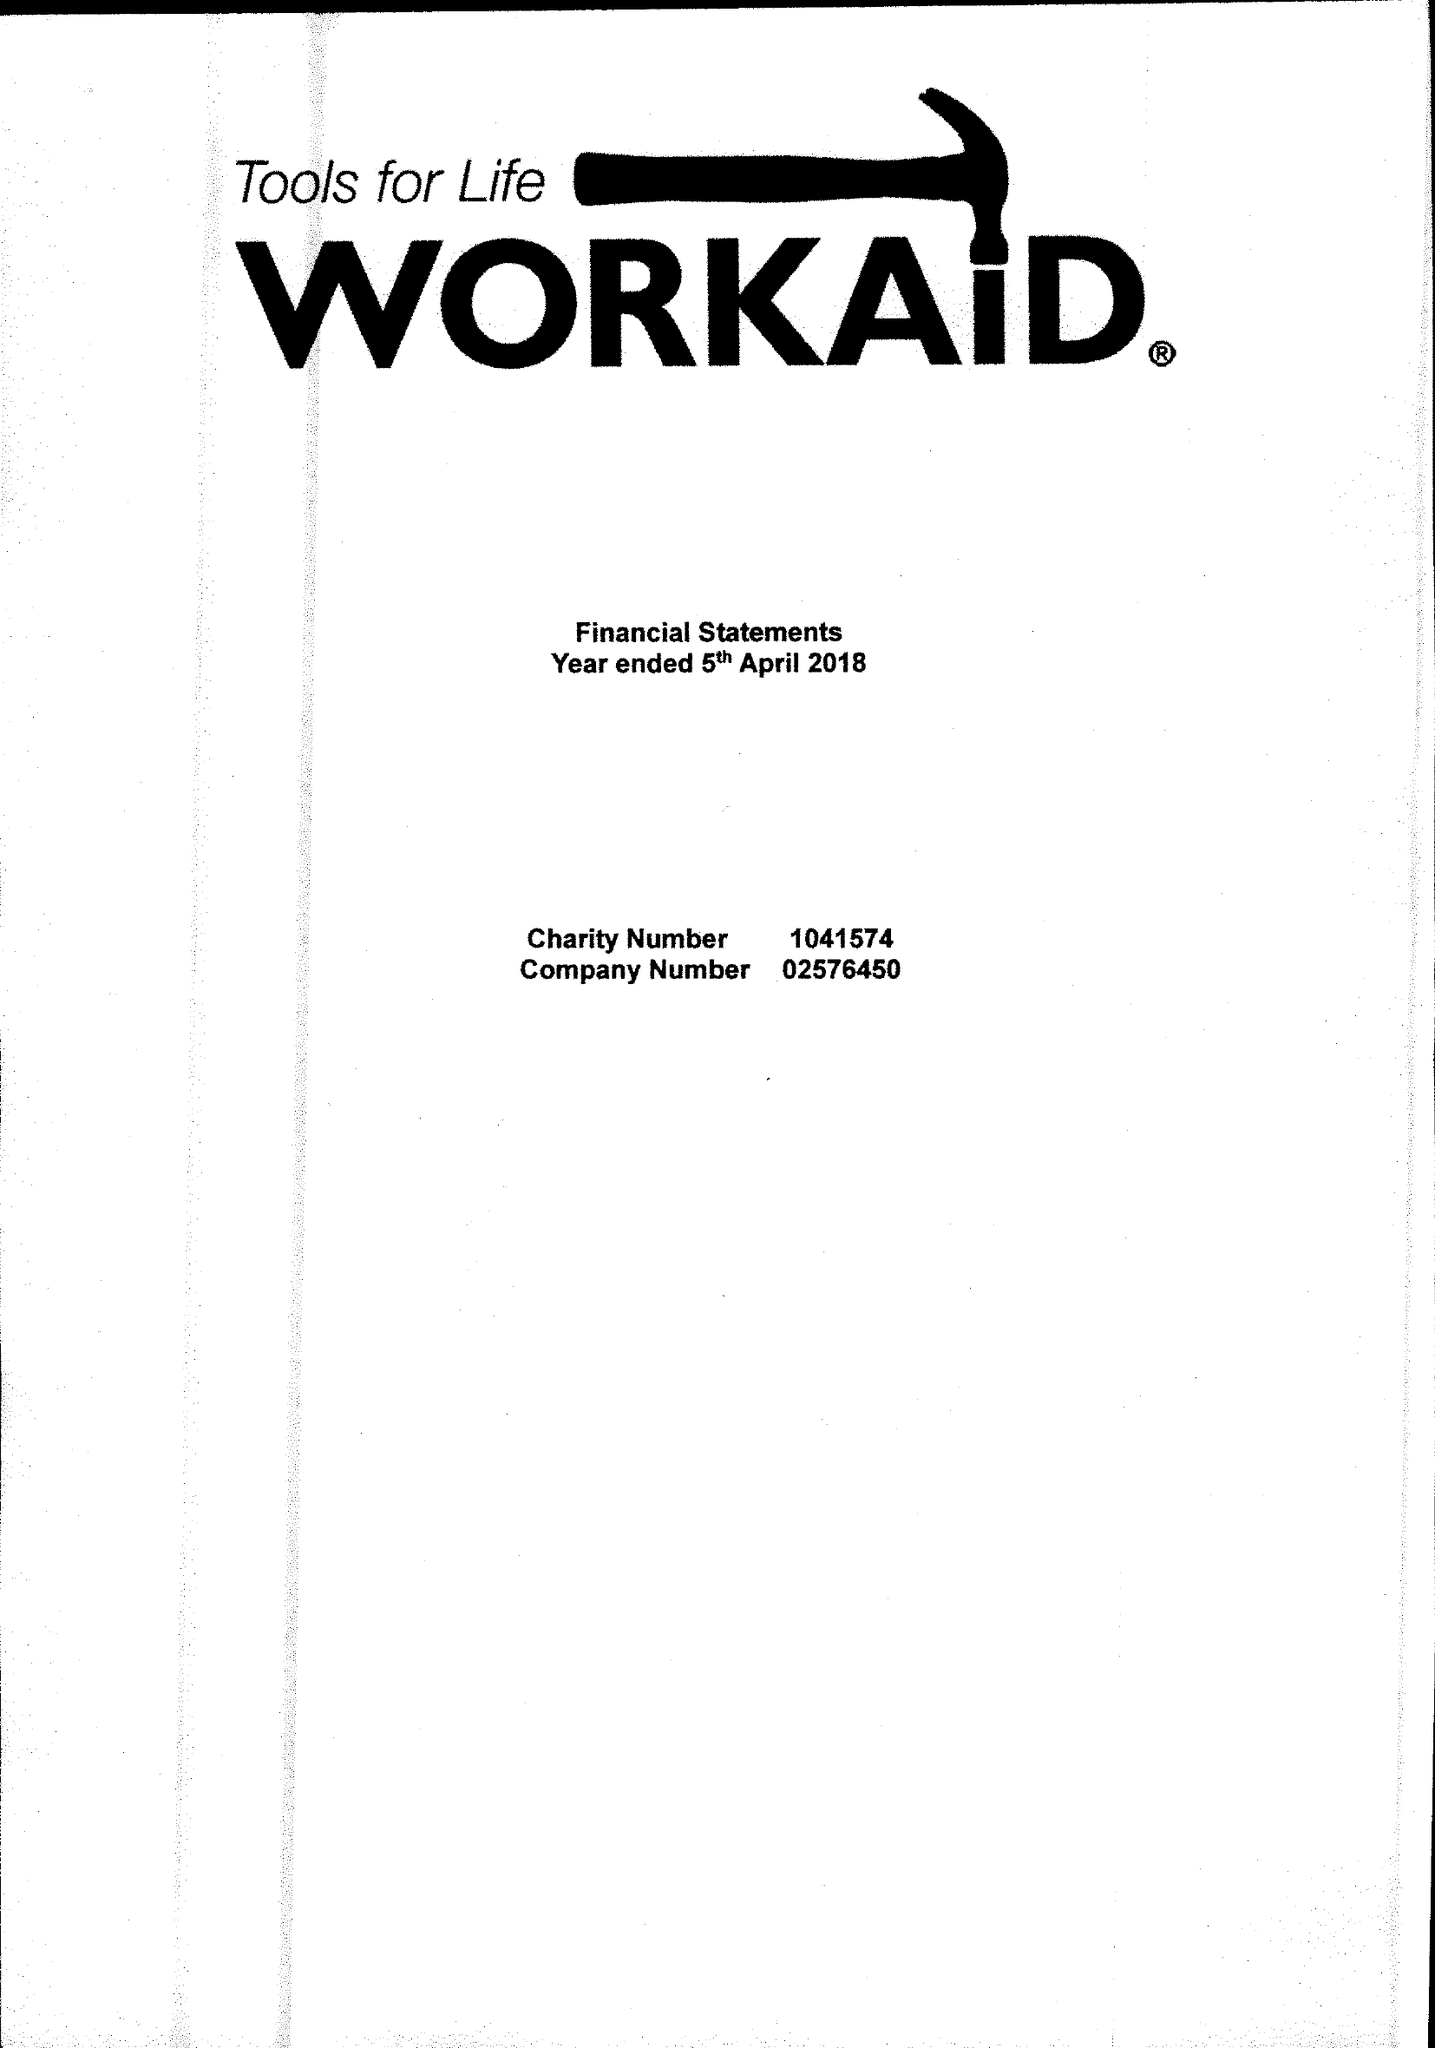What is the value for the address__postcode?
Answer the question using a single word or phrase. HP5 2AA 